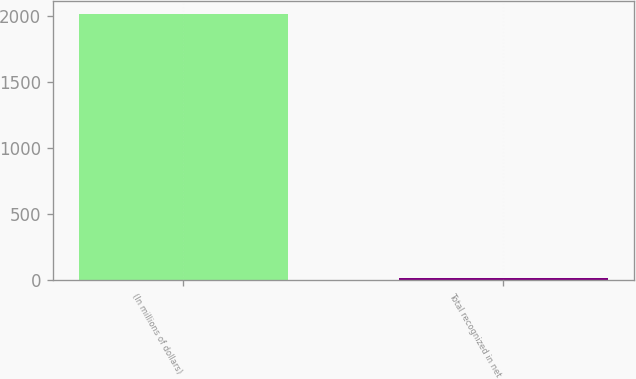Convert chart to OTSL. <chart><loc_0><loc_0><loc_500><loc_500><bar_chart><fcel>(In millions of dollars)<fcel>Total recognized in net<nl><fcel>2014<fcel>14<nl></chart> 